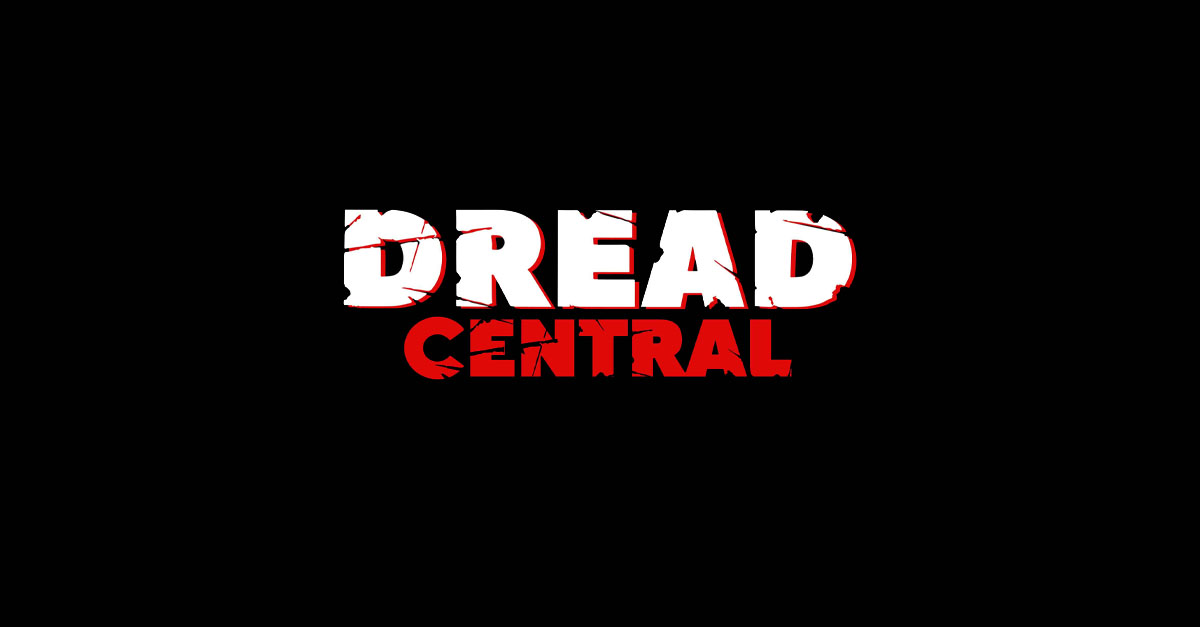Aside from the obvious horror connotations, what might 'CENTRAL' imply about the purpose or content the design is associated with? The inclusion of 'CENTRAL' in the design suggests a focal point or gathering place for a community or collection of content. It implies that the entity represented by this text serves as a hub or core facility that is central to the interests it caters to, in this case, likely horror and suspense. This could mean a platform or an organization that specializes in bringing together stories, reviews, discussions, or resources pivotal to the horror genre, indicating a central role in the cultivation and dissemination of this thematic content.  How do you think the black background contributes to the overall message the design is trying to convey? The black background serves multiple purposes in this design. It helps the red and white text stand out starkly, adding visual impact and ensuring immediate attention. On a symbolic level, black often represents darkness, mystery, and the unknown—all typical elements of suspense and horror. It acts as a canvas for the mind, where the shadows can play tricks and fear can fester, further evoking the dread the typography suggests. This makes it an ideal choice for establishing the foreboding atmosphere that fans of the genre so deeply appreciate. 